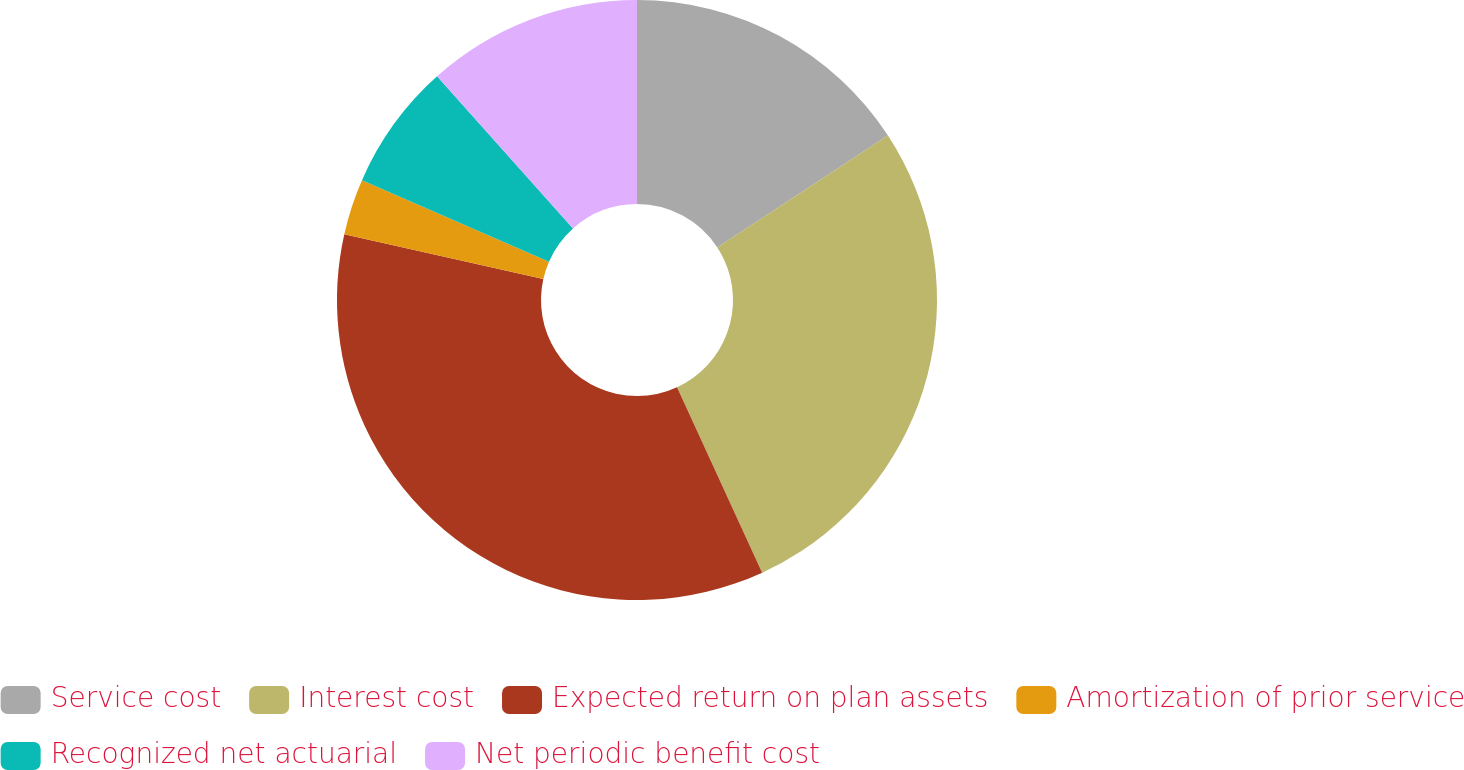Convert chart to OTSL. <chart><loc_0><loc_0><loc_500><loc_500><pie_chart><fcel>Service cost<fcel>Interest cost<fcel>Expected return on plan assets<fcel>Amortization of prior service<fcel>Recognized net actuarial<fcel>Net periodic benefit cost<nl><fcel>15.77%<fcel>27.38%<fcel>35.37%<fcel>3.02%<fcel>6.85%<fcel>11.61%<nl></chart> 